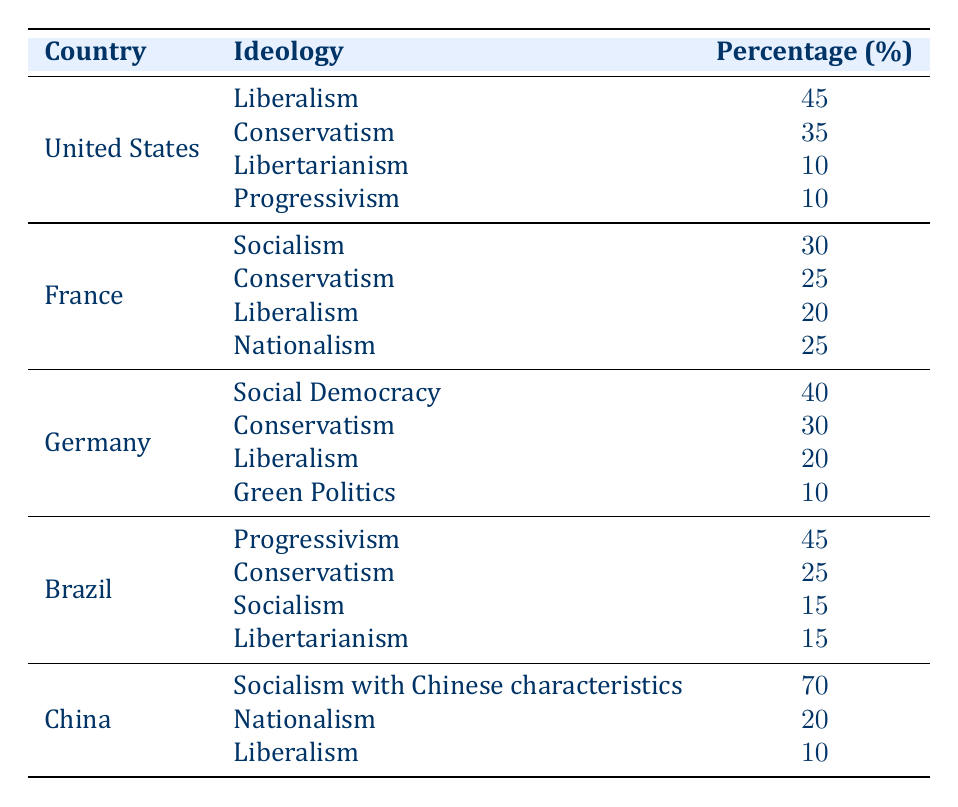What is the most prevalent political ideology in the United States? By examining the rows for the United States, we see that Liberalism has the highest percentage at 45%.
Answer: Liberalism Which country has a stronger presence of Conservatism, the United States or Brazil? In the United States, Conservatism is at 35%, while in Brazil, it is at 25%. Therefore, the United States has a stronger presence of Conservatism.
Answer: United States What is the average percentage of Liberalism across the provided countries? The percentages of Liberalism are 45 (US), 20 (France), 20 (Germany), 0 (Brazil), and 10 (China). Summing these gives 95, and dividing by 5 (the number of entries) results in an average of 19%.
Answer: 19% Is Socialism the dominant ideology in China? In China, the percentage for Socialism with Chinese characteristics is 70%, which is higher than other ideologies listed for China. Hence, it can be considered the dominant ideology there.
Answer: Yes Which political ideology has the lowest percentage in Germany? The ideologies for Germany are Social Democracy (40%), Conservatism (30%), Liberalism (20%), and Green Politics (10%). Green Politics at 10% has the lowest percentage.
Answer: Green Politics What is the total percentage of Progressivism in both the United States and Brazil? The United States has 10% for Progressivism and Brazil has 45%. Adding these together results in 55%.
Answer: 55% Does France have a higher percentage of Nationalism than the United States? France has a percentage of 25% for Nationalism, while the United States does not list Nationalism as a separate ideology. Hence, comparing the two shows that France has a higher percentage.
Answer: Yes Which country shows the least diversity in political ideologies based on the data? By reviewing the percentages, China has only 3 ideologies represented, while others have more (e.g., the US has 4, Brazil has 4). Therefore, China shows the least diversity.
Answer: China 